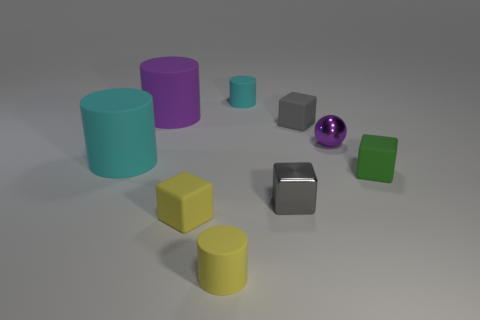What shape is the other metal object that is the same size as the purple metallic thing?
Your response must be concise. Cube. Are the purple thing that is on the left side of the purple metallic ball and the block that is right of the shiny ball made of the same material?
Give a very brief answer. Yes. Are there any green matte objects that are on the right side of the metal thing that is behind the small green rubber cube?
Keep it short and to the point. Yes. There is a small cylinder that is made of the same material as the tiny cyan object; what is its color?
Provide a short and direct response. Yellow. Are there more tiny metallic things than small gray spheres?
Your response must be concise. Yes. How many objects are big cylinders in front of the small gray rubber object or cyan spheres?
Make the answer very short. 1. Is there another green metallic cube of the same size as the green block?
Your answer should be very brief. No. Are there fewer large gray shiny blocks than large purple matte objects?
Your response must be concise. Yes. What number of cubes are matte things or green matte things?
Offer a very short reply. 3. How many blocks have the same color as the small metal ball?
Offer a terse response. 0. 